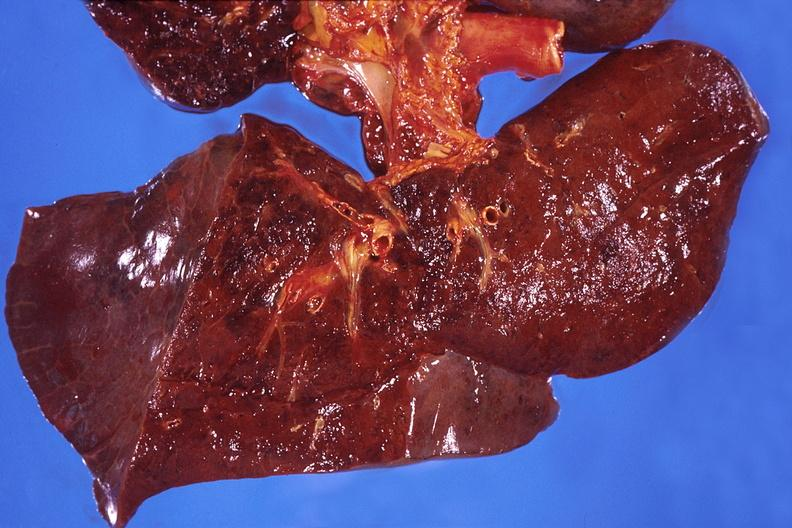what does this image show?
Answer the question using a single word or phrase. Lung 